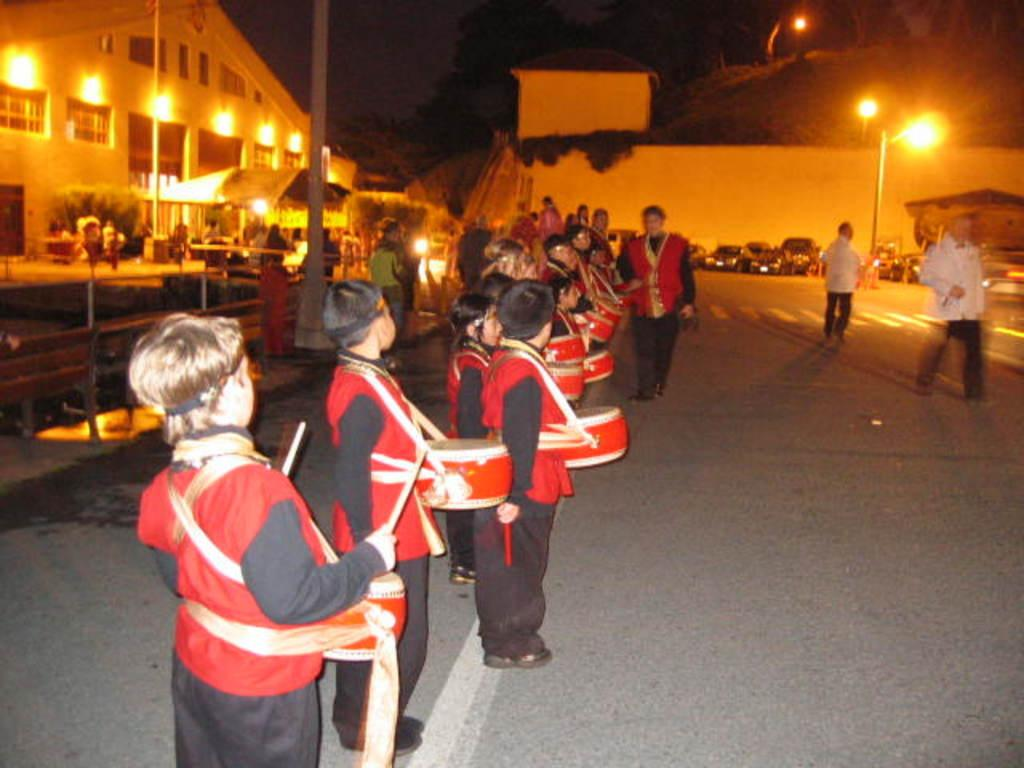What are the persons on the ground doing in the image? The persons on the ground are holding drums. What type of structures can be seen in the image? There are houses in the image. What can be seen illuminated in the image? Lights are visible in the image. What are the vertical structures in the image used for? Poles are present in the image, which may be used for various purposes such as supporting wires or signs. What type of transportation is visible in the image? Vehicles are in the image. What type of natural elements are present in the image? Plants and trees are in the image. How would you describe the lighting conditions in the image? The background of the image is dark. What type of jail can be seen in the image? There is no jail present in the image. What is the current flowing through the plants in the image? There is no mention of current or electricity in the image, and plants do not require current to function. 